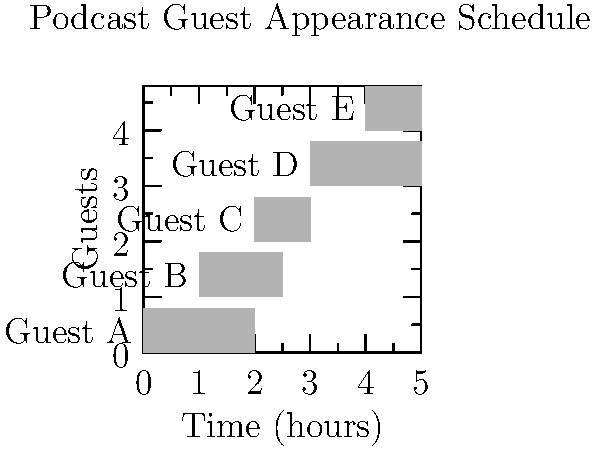As a PR specialist managing a podcast's guest appearances, you're presented with the Gantt chart above showing the schedule for five guests. If you need to schedule a 30-minute break between each guest for setup and transition, what is the minimum total time required to complete all interviews, including the breaks? To solve this problem, we need to:

1. Identify the start and end times for each guest:
   Guest A: 0-2 hours
   Guest B: 1-2.5 hours
   Guest C: 2-3 hours
   Guest D: 3-5 hours
   Guest E: 4-5 hours

2. Determine the overall time span:
   The schedule starts at 0 and ends at 5 hours.

3. Count the number of transitions needed:
   There are 5 guests, so we need 4 transitions.

4. Calculate the total transition time:
   4 transitions × 0.5 hours = 2 hours

5. Add the transition time to the overall time span:
   5 hours (original span) + 2 hours (transitions) = 7 hours

Therefore, the minimum total time required to complete all interviews, including the 30-minute breaks between guests, is 7 hours.
Answer: 7 hours 